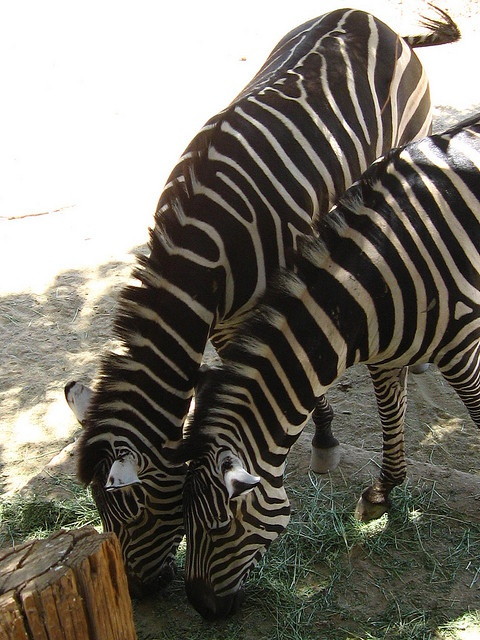Describe the objects in this image and their specific colors. I can see zebra in white, black, gray, and darkgray tones and zebra in white, black, gray, and darkgray tones in this image. 